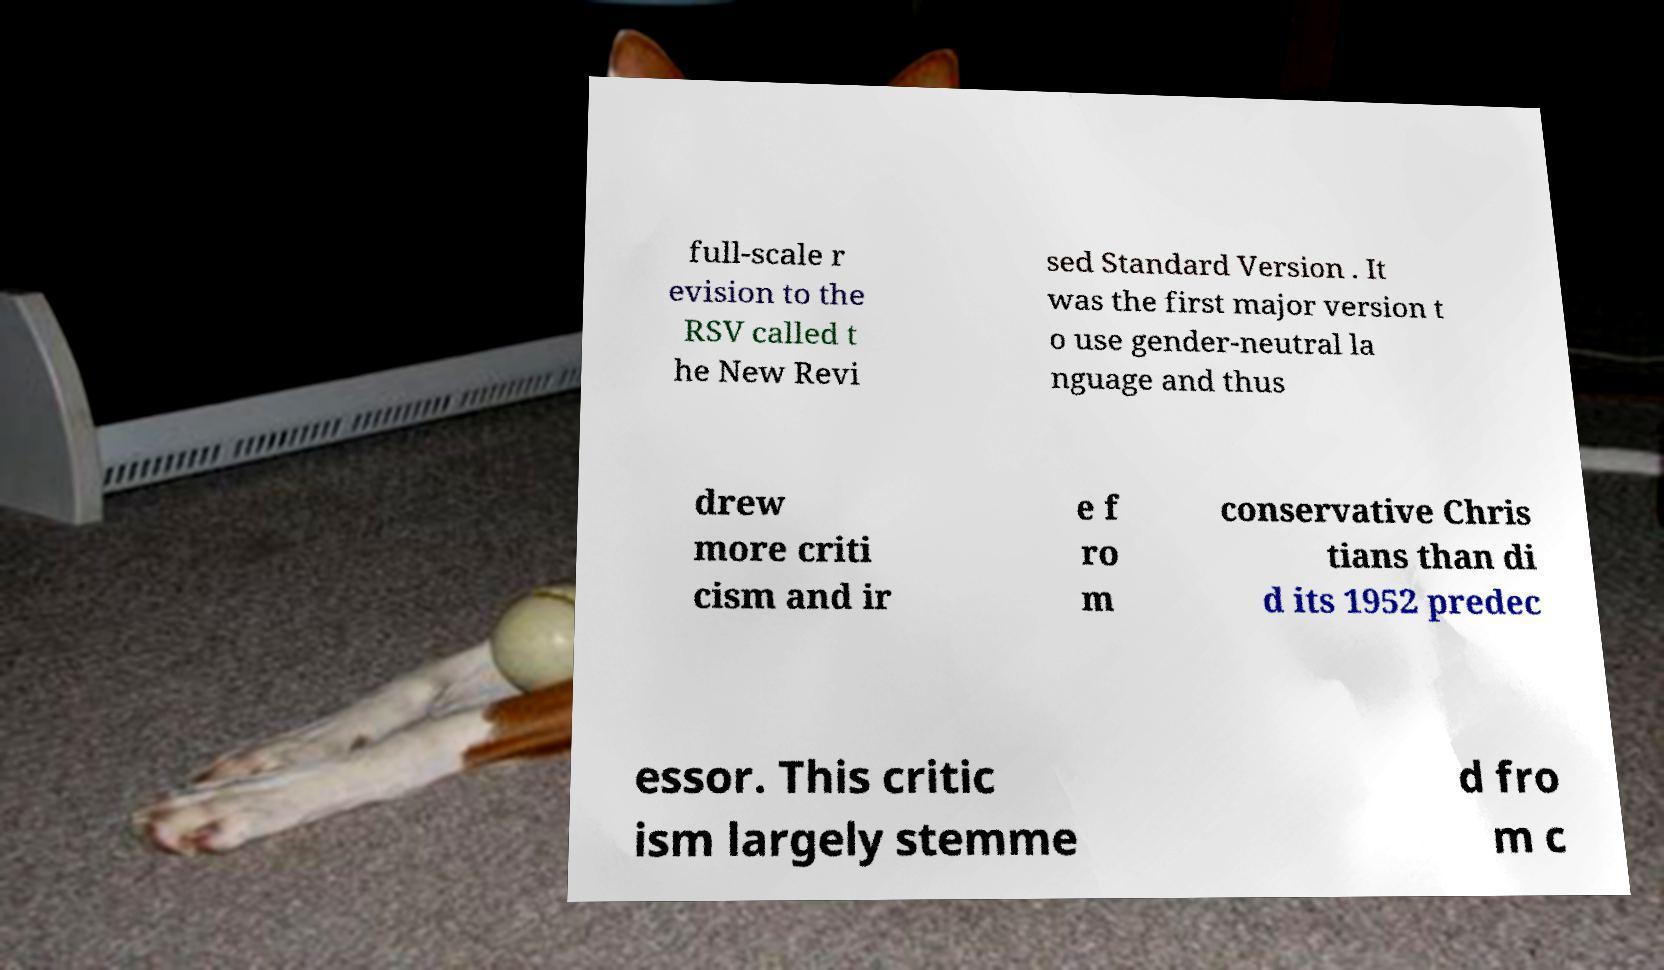Could you extract and type out the text from this image? full-scale r evision to the RSV called t he New Revi sed Standard Version . It was the first major version t o use gender-neutral la nguage and thus drew more criti cism and ir e f ro m conservative Chris tians than di d its 1952 predec essor. This critic ism largely stemme d fro m c 